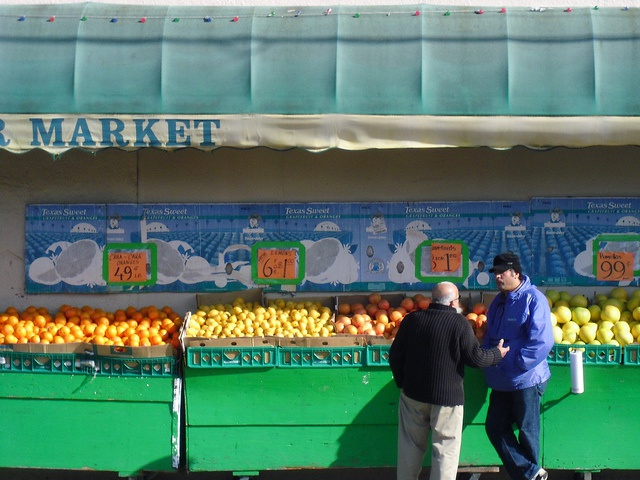Describe the objects in this image and their specific colors. I can see people in white, black, purple, lightgray, and darkgray tones, people in white, black, navy, blue, and green tones, apple in white, gold, orange, khaki, and olive tones, apple in white, olive, and khaki tones, and orange in white, orange, red, gold, and maroon tones in this image. 